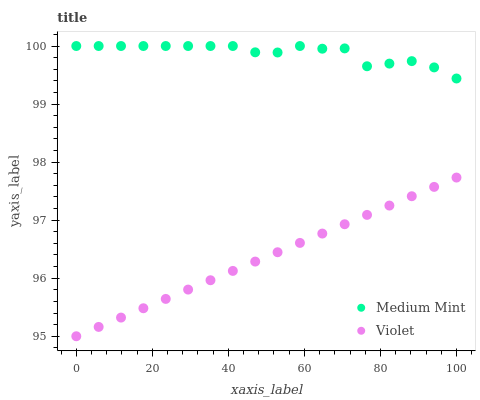Does Violet have the minimum area under the curve?
Answer yes or no. Yes. Does Medium Mint have the maximum area under the curve?
Answer yes or no. Yes. Does Violet have the maximum area under the curve?
Answer yes or no. No. Is Violet the smoothest?
Answer yes or no. Yes. Is Medium Mint the roughest?
Answer yes or no. Yes. Is Violet the roughest?
Answer yes or no. No. Does Violet have the lowest value?
Answer yes or no. Yes. Does Medium Mint have the highest value?
Answer yes or no. Yes. Does Violet have the highest value?
Answer yes or no. No. Is Violet less than Medium Mint?
Answer yes or no. Yes. Is Medium Mint greater than Violet?
Answer yes or no. Yes. Does Violet intersect Medium Mint?
Answer yes or no. No. 